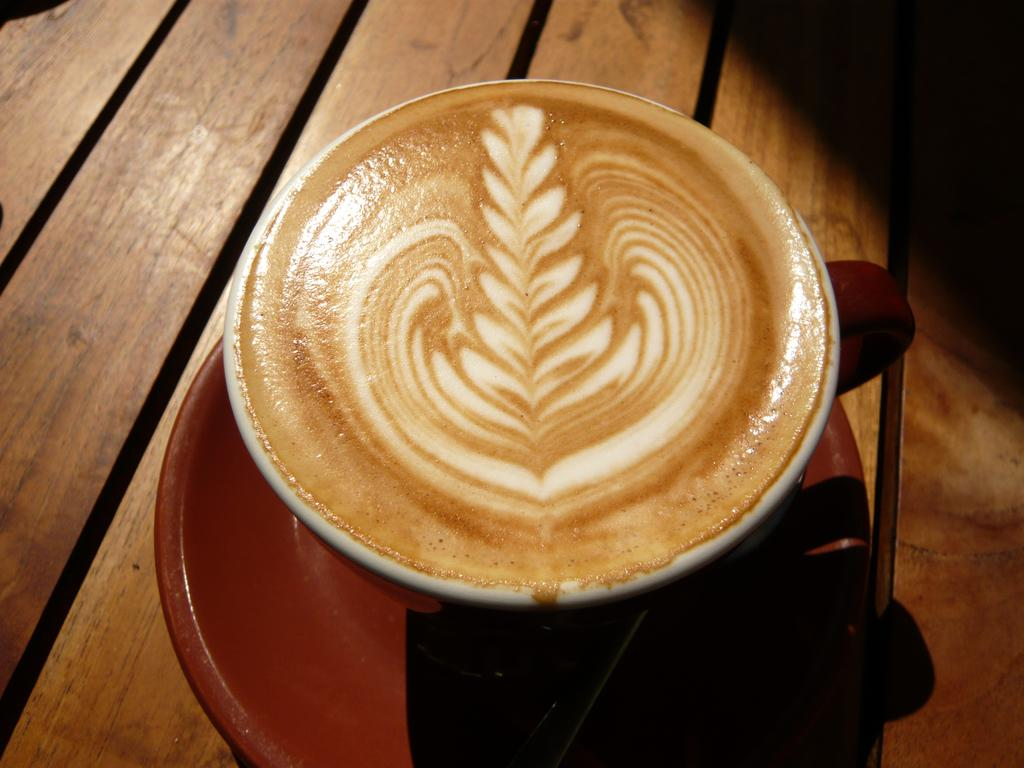What piece of furniture is present in the image? There is a table in the image. What is placed on the table? There is a coffee cup and a saucer on the table. What type of iron can be seen on the table in the image? There is no iron present on the table in the image. 